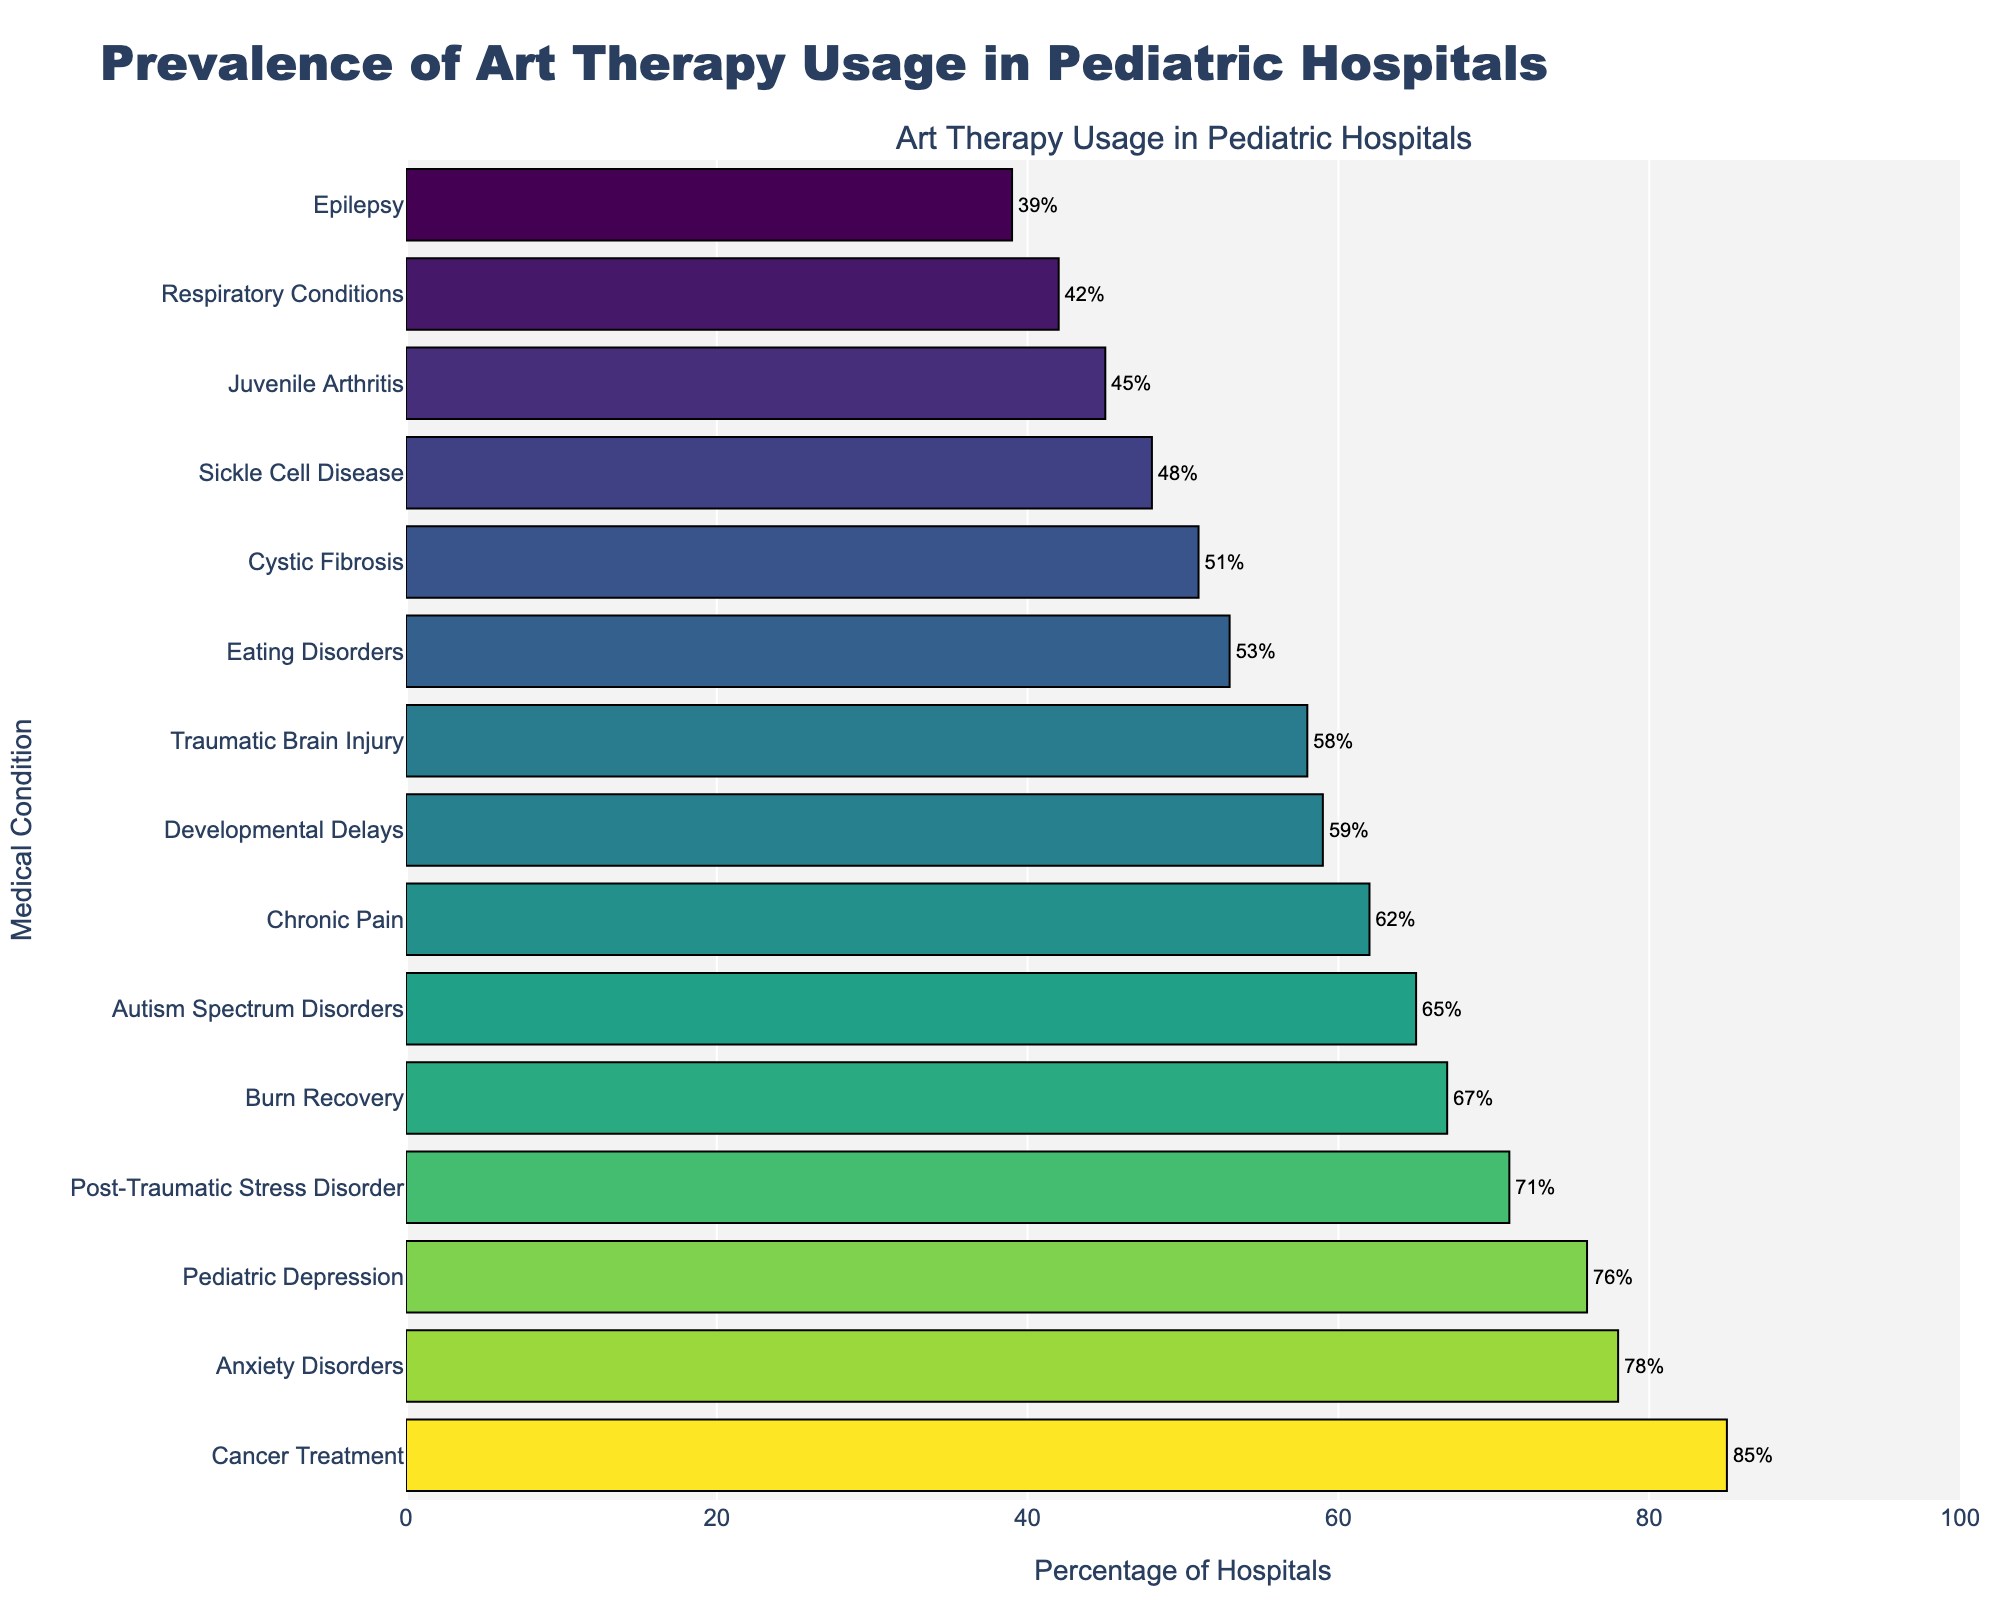What medical condition has the highest prevalence of art therapy usage in pediatric hospitals? The bar with the highest length in the chart represents the medical condition with the highest usage. Observing the chart, the medical condition associated with the highest bar is Cancer Treatment, having a length corresponding to 85%.
Answer: Cancer Treatment Which two medical conditions have between 60% and 70% prevalence of art therapy usage in pediatric hospitals? Two bars within the 60%-70% range should be identified by their lengths. The chart shows that Chronic Pain (62%) and Burn Recovery (67%) are in this range.
Answer: Chronic Pain and Burn Recovery What is the difference in the percentage of art therapy usage between Anxiety Disorders and Autism Spectrum Disorders? To find the difference, subtract the percentage for Autism Spectrum Disorders from that for Anxiety Disorders. Anxiety Disorders have 78% and Autism Spectrum Disorders have 65%. The difference is 78% - 65% = 13%.
Answer: 13% What are the median percentages of art therapy usage? To find the median, list all percentages in ascending order and find the middle value(s). The sorted percentages are: 39, 42, 45, 48, 51, 53, 58, 59, 62, 65, 67, 71, 76, 78, 85. With 15 values, the median is the 8th value, which is 59.
Answer: 59% Which condition shows a relatively lower prevalence of art therapy usage, Pediatric Depression or Post-Traumatic Stress Disorder? Comparing the bars for these two conditions, Post-Traumatic Stress Disorder (71%) and Pediatric Depression (76%), the one with the lower value is identified. The value for Post-Traumatic Stress Disorder is lower.
Answer: Post-Traumatic Stress Disorder Is the prevalence of art therapy usage for Epilepsy greater than that for Respiratory Conditions? Compare the bar lengths for Epilepsy (39%) and Respiratory Conditions (42%). Epilepsy has a lower percentage compared to Respiratory Conditions.
Answer: No What is the average prevalence of art therapy usage across all listed medical conditions? Sum all the percentages and divide by the number of conditions. (78 + 65 + 62 + 85 + 58 + 53 + 71 + 67 + 42 + 59 + 48 + 39 + 45 + 51 + 76) = 899. There are 15 conditions, so the average is 899 / 15 = approximately 59.93%.
Answer: Approximately 59.93% Which medical condition shows less than 50% prevalence of art therapy usage and is closest to the 50% threshold? Identify all conditions under 50%, then find the one closest to 50%. The relevant percentages are 48% (Sickle Cell Disease), 45% (Juvenile Arthritis), and 39% (Epilepsy). Sickle Cell Disease is closest to 50%.
Answer: Sickle Cell Disease 